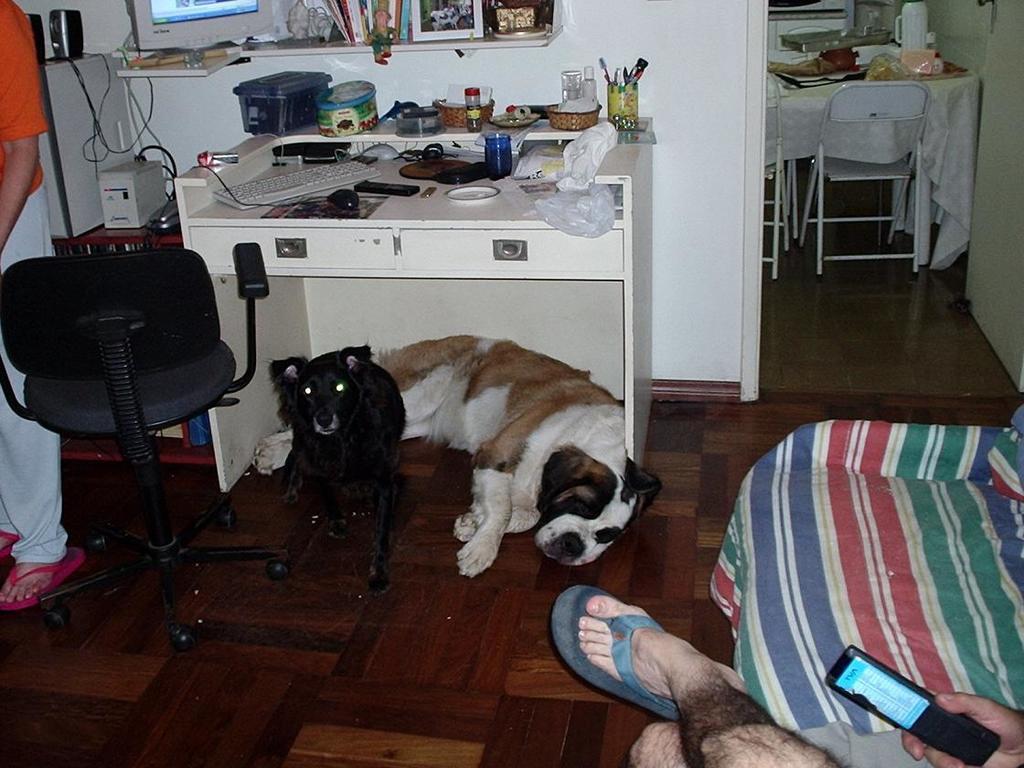In one or two sentences, can you explain what this image depicts? This picture is clicked inside the room. In middle of the picture, we see a table on which tape, mouse, keyboard, remote, plastic cover, plastic box containing pens are placed on this table. We see white and black dog are sitting under the chair under the table. Behind the table, we see selves in which photo frame, books and system are placed. On the right bottom of the picture, we see man holding mobile phone in his hand is sitting on bed and on right top of the picture, we see dining table and chair. 